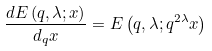Convert formula to latex. <formula><loc_0><loc_0><loc_500><loc_500>\frac { d E \left ( q , \lambda ; x \right ) } { d _ { q } x } = E \left ( q , \lambda ; q ^ { 2 \lambda } x \right )</formula> 